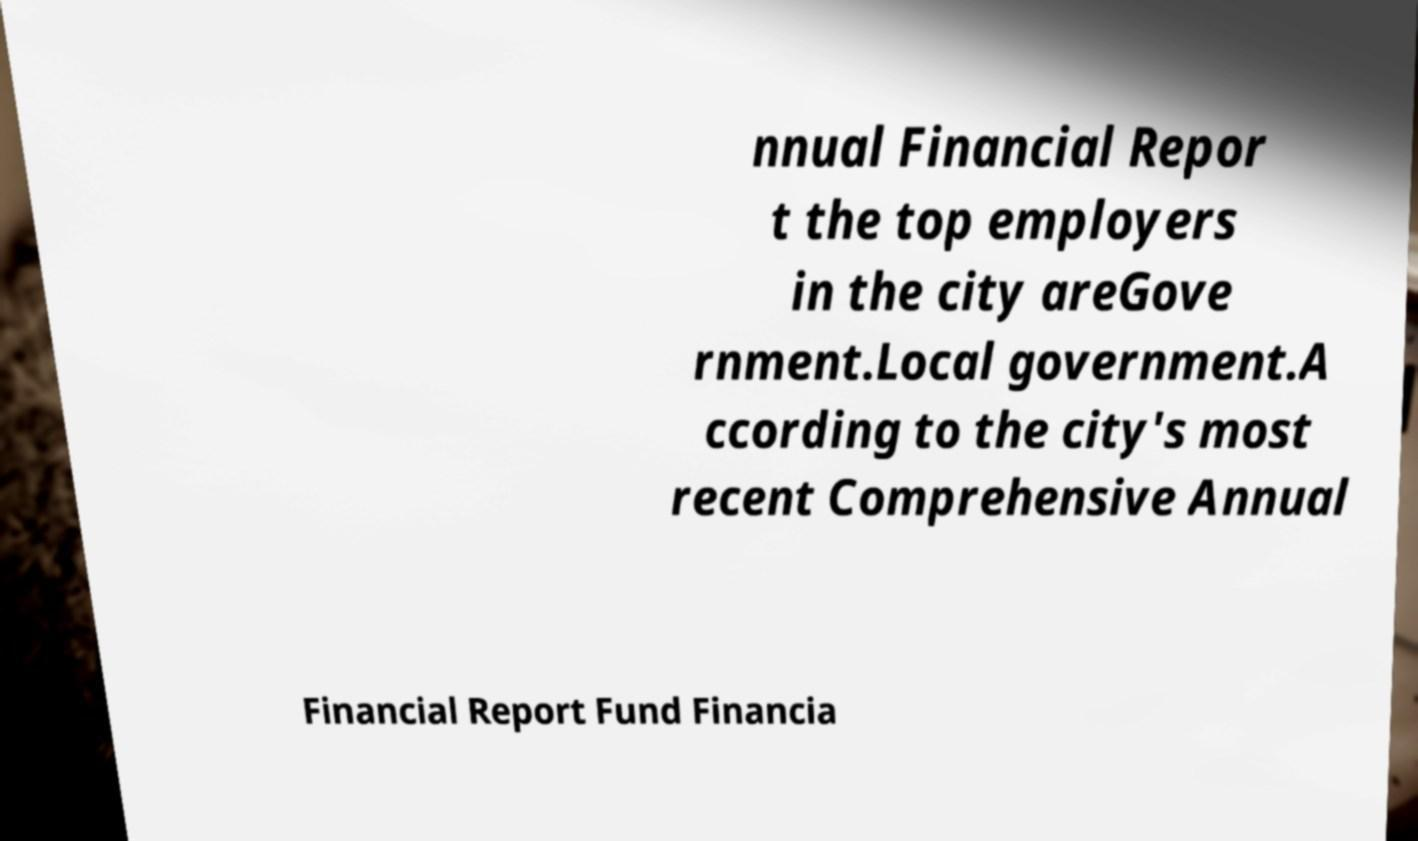Could you assist in decoding the text presented in this image and type it out clearly? nnual Financial Repor t the top employers in the city areGove rnment.Local government.A ccording to the city's most recent Comprehensive Annual Financial Report Fund Financia 